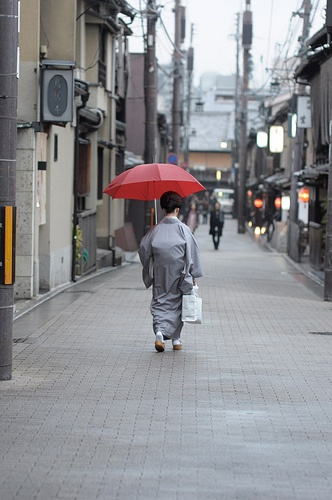Describe the objects in this image and their specific colors. I can see people in black, gray, and darkgray tones, umbrella in black, brown, lightpink, and salmon tones, handbag in black, lightgray, and darkgray tones, people in black, gray, darkgray, and purple tones, and car in black, darkgray, gray, and lightgray tones in this image. 